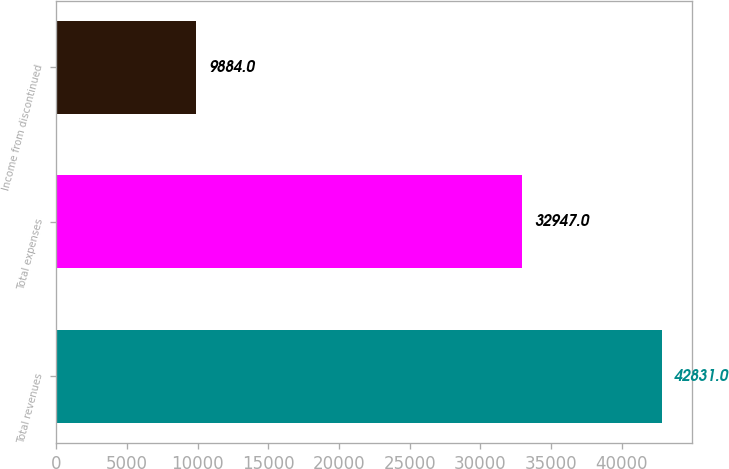Convert chart. <chart><loc_0><loc_0><loc_500><loc_500><bar_chart><fcel>Total revenues<fcel>Total expenses<fcel>Income from discontinued<nl><fcel>42831<fcel>32947<fcel>9884<nl></chart> 